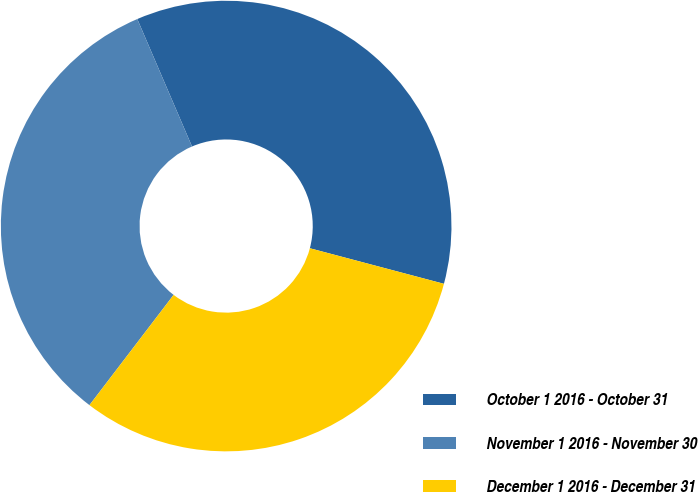Convert chart. <chart><loc_0><loc_0><loc_500><loc_500><pie_chart><fcel>October 1 2016 - October 31<fcel>November 1 2016 - November 30<fcel>December 1 2016 - December 31<nl><fcel>35.58%<fcel>33.17%<fcel>31.25%<nl></chart> 